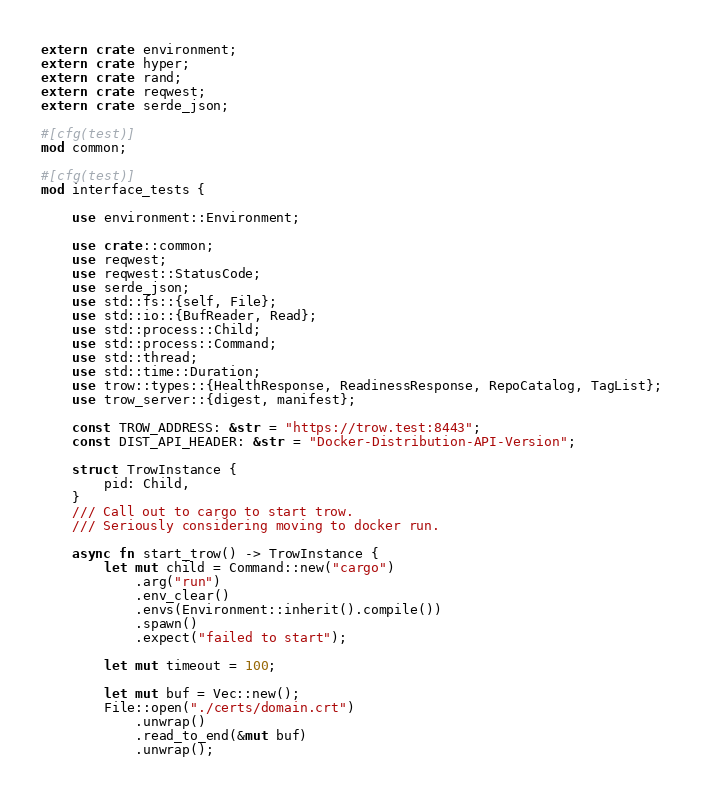Convert code to text. <code><loc_0><loc_0><loc_500><loc_500><_Rust_>extern crate environment;
extern crate hyper;
extern crate rand;
extern crate reqwest;
extern crate serde_json;

#[cfg(test)]
mod common;

#[cfg(test)]
mod interface_tests {

    use environment::Environment;

    use crate::common;
    use reqwest;
    use reqwest::StatusCode;
    use serde_json;
    use std::fs::{self, File};
    use std::io::{BufReader, Read};
    use std::process::Child;
    use std::process::Command;
    use std::thread;
    use std::time::Duration;
    use trow::types::{HealthResponse, ReadinessResponse, RepoCatalog, TagList};
    use trow_server::{digest, manifest};

    const TROW_ADDRESS: &str = "https://trow.test:8443";
    const DIST_API_HEADER: &str = "Docker-Distribution-API-Version";

    struct TrowInstance {
        pid: Child,
    }
    /// Call out to cargo to start trow.
    /// Seriously considering moving to docker run.

    async fn start_trow() -> TrowInstance {
        let mut child = Command::new("cargo")
            .arg("run")
            .env_clear()
            .envs(Environment::inherit().compile())
            .spawn()
            .expect("failed to start");

        let mut timeout = 100;

        let mut buf = Vec::new();
        File::open("./certs/domain.crt")
            .unwrap()
            .read_to_end(&mut buf)
            .unwrap();</code> 